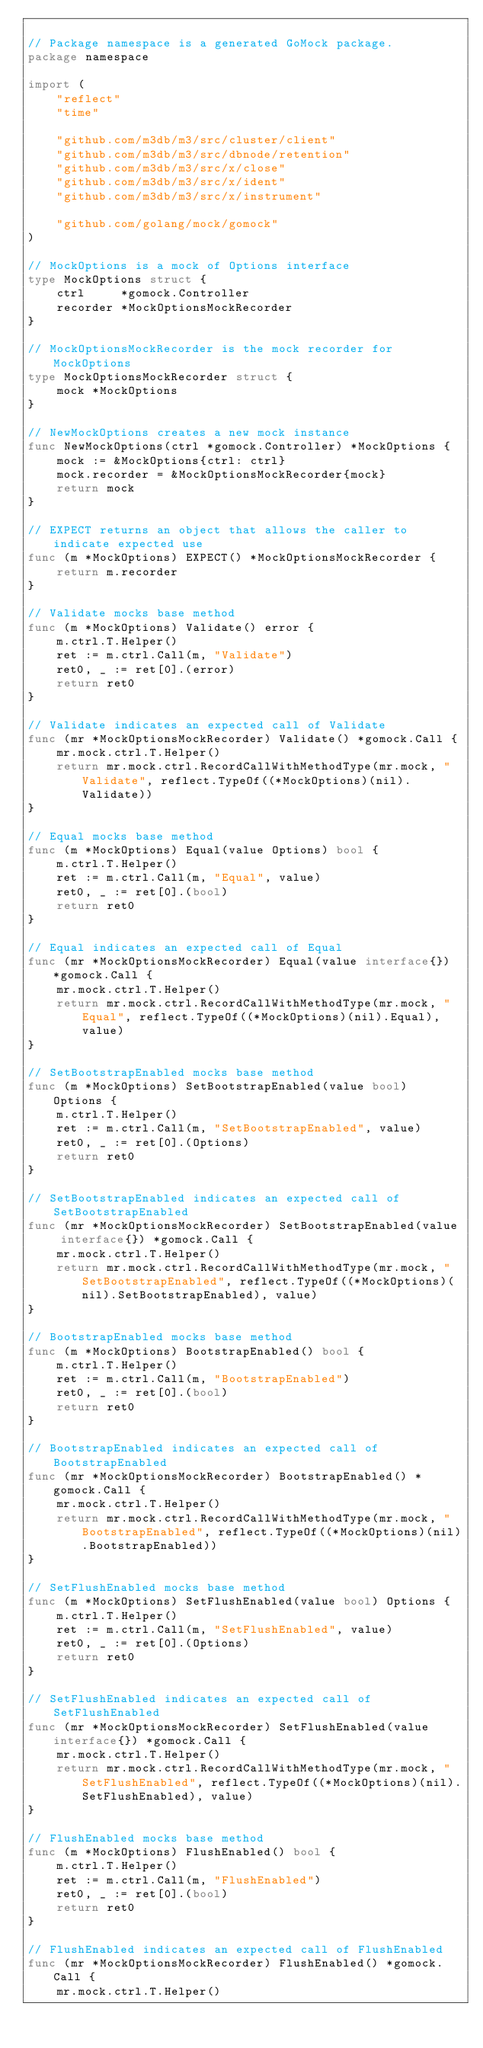<code> <loc_0><loc_0><loc_500><loc_500><_Go_>
// Package namespace is a generated GoMock package.
package namespace

import (
	"reflect"
	"time"

	"github.com/m3db/m3/src/cluster/client"
	"github.com/m3db/m3/src/dbnode/retention"
	"github.com/m3db/m3/src/x/close"
	"github.com/m3db/m3/src/x/ident"
	"github.com/m3db/m3/src/x/instrument"

	"github.com/golang/mock/gomock"
)

// MockOptions is a mock of Options interface
type MockOptions struct {
	ctrl     *gomock.Controller
	recorder *MockOptionsMockRecorder
}

// MockOptionsMockRecorder is the mock recorder for MockOptions
type MockOptionsMockRecorder struct {
	mock *MockOptions
}

// NewMockOptions creates a new mock instance
func NewMockOptions(ctrl *gomock.Controller) *MockOptions {
	mock := &MockOptions{ctrl: ctrl}
	mock.recorder = &MockOptionsMockRecorder{mock}
	return mock
}

// EXPECT returns an object that allows the caller to indicate expected use
func (m *MockOptions) EXPECT() *MockOptionsMockRecorder {
	return m.recorder
}

// Validate mocks base method
func (m *MockOptions) Validate() error {
	m.ctrl.T.Helper()
	ret := m.ctrl.Call(m, "Validate")
	ret0, _ := ret[0].(error)
	return ret0
}

// Validate indicates an expected call of Validate
func (mr *MockOptionsMockRecorder) Validate() *gomock.Call {
	mr.mock.ctrl.T.Helper()
	return mr.mock.ctrl.RecordCallWithMethodType(mr.mock, "Validate", reflect.TypeOf((*MockOptions)(nil).Validate))
}

// Equal mocks base method
func (m *MockOptions) Equal(value Options) bool {
	m.ctrl.T.Helper()
	ret := m.ctrl.Call(m, "Equal", value)
	ret0, _ := ret[0].(bool)
	return ret0
}

// Equal indicates an expected call of Equal
func (mr *MockOptionsMockRecorder) Equal(value interface{}) *gomock.Call {
	mr.mock.ctrl.T.Helper()
	return mr.mock.ctrl.RecordCallWithMethodType(mr.mock, "Equal", reflect.TypeOf((*MockOptions)(nil).Equal), value)
}

// SetBootstrapEnabled mocks base method
func (m *MockOptions) SetBootstrapEnabled(value bool) Options {
	m.ctrl.T.Helper()
	ret := m.ctrl.Call(m, "SetBootstrapEnabled", value)
	ret0, _ := ret[0].(Options)
	return ret0
}

// SetBootstrapEnabled indicates an expected call of SetBootstrapEnabled
func (mr *MockOptionsMockRecorder) SetBootstrapEnabled(value interface{}) *gomock.Call {
	mr.mock.ctrl.T.Helper()
	return mr.mock.ctrl.RecordCallWithMethodType(mr.mock, "SetBootstrapEnabled", reflect.TypeOf((*MockOptions)(nil).SetBootstrapEnabled), value)
}

// BootstrapEnabled mocks base method
func (m *MockOptions) BootstrapEnabled() bool {
	m.ctrl.T.Helper()
	ret := m.ctrl.Call(m, "BootstrapEnabled")
	ret0, _ := ret[0].(bool)
	return ret0
}

// BootstrapEnabled indicates an expected call of BootstrapEnabled
func (mr *MockOptionsMockRecorder) BootstrapEnabled() *gomock.Call {
	mr.mock.ctrl.T.Helper()
	return mr.mock.ctrl.RecordCallWithMethodType(mr.mock, "BootstrapEnabled", reflect.TypeOf((*MockOptions)(nil).BootstrapEnabled))
}

// SetFlushEnabled mocks base method
func (m *MockOptions) SetFlushEnabled(value bool) Options {
	m.ctrl.T.Helper()
	ret := m.ctrl.Call(m, "SetFlushEnabled", value)
	ret0, _ := ret[0].(Options)
	return ret0
}

// SetFlushEnabled indicates an expected call of SetFlushEnabled
func (mr *MockOptionsMockRecorder) SetFlushEnabled(value interface{}) *gomock.Call {
	mr.mock.ctrl.T.Helper()
	return mr.mock.ctrl.RecordCallWithMethodType(mr.mock, "SetFlushEnabled", reflect.TypeOf((*MockOptions)(nil).SetFlushEnabled), value)
}

// FlushEnabled mocks base method
func (m *MockOptions) FlushEnabled() bool {
	m.ctrl.T.Helper()
	ret := m.ctrl.Call(m, "FlushEnabled")
	ret0, _ := ret[0].(bool)
	return ret0
}

// FlushEnabled indicates an expected call of FlushEnabled
func (mr *MockOptionsMockRecorder) FlushEnabled() *gomock.Call {
	mr.mock.ctrl.T.Helper()</code> 